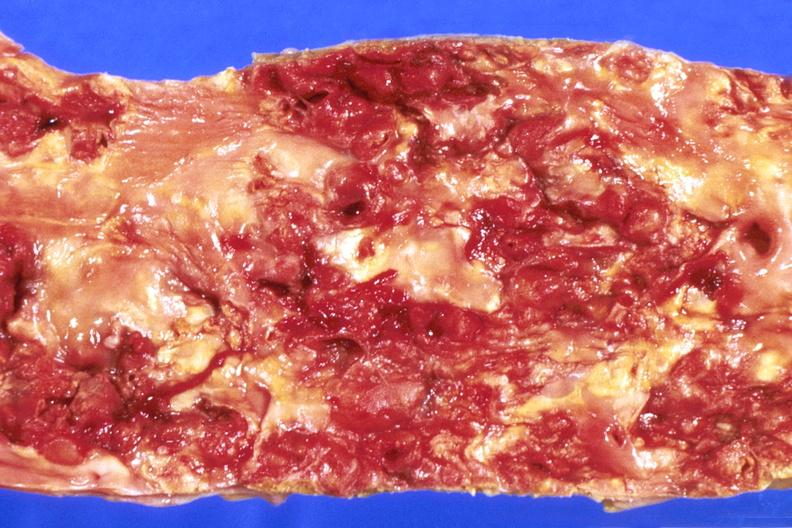does an opened peritoneal cavity cause by fibrous band strangulation show abdominal aorta, severe atherosclerosis?
Answer the question using a single word or phrase. No 